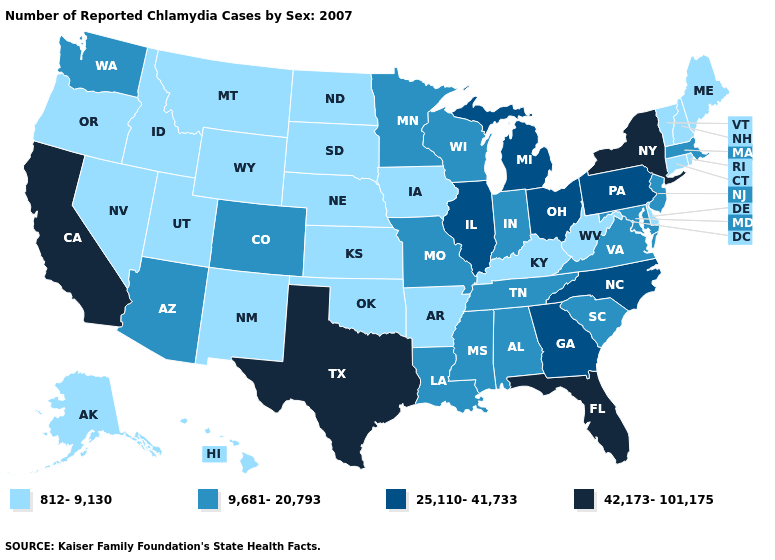What is the value of Illinois?
Concise answer only. 25,110-41,733. What is the value of Kansas?
Concise answer only. 812-9,130. Which states have the lowest value in the Northeast?
Short answer required. Connecticut, Maine, New Hampshire, Rhode Island, Vermont. What is the value of South Dakota?
Answer briefly. 812-9,130. Name the states that have a value in the range 42,173-101,175?
Quick response, please. California, Florida, New York, Texas. Among the states that border Nevada , does Arizona have the highest value?
Write a very short answer. No. Name the states that have a value in the range 9,681-20,793?
Be succinct. Alabama, Arizona, Colorado, Indiana, Louisiana, Maryland, Massachusetts, Minnesota, Mississippi, Missouri, New Jersey, South Carolina, Tennessee, Virginia, Washington, Wisconsin. What is the value of Vermont?
Answer briefly. 812-9,130. What is the lowest value in the West?
Give a very brief answer. 812-9,130. Does North Carolina have the lowest value in the USA?
Concise answer only. No. Does Minnesota have the highest value in the USA?
Answer briefly. No. Among the states that border North Carolina , does Virginia have the lowest value?
Give a very brief answer. Yes. Name the states that have a value in the range 812-9,130?
Keep it brief. Alaska, Arkansas, Connecticut, Delaware, Hawaii, Idaho, Iowa, Kansas, Kentucky, Maine, Montana, Nebraska, Nevada, New Hampshire, New Mexico, North Dakota, Oklahoma, Oregon, Rhode Island, South Dakota, Utah, Vermont, West Virginia, Wyoming. What is the value of New Jersey?
Write a very short answer. 9,681-20,793. Does South Dakota have the highest value in the USA?
Quick response, please. No. 